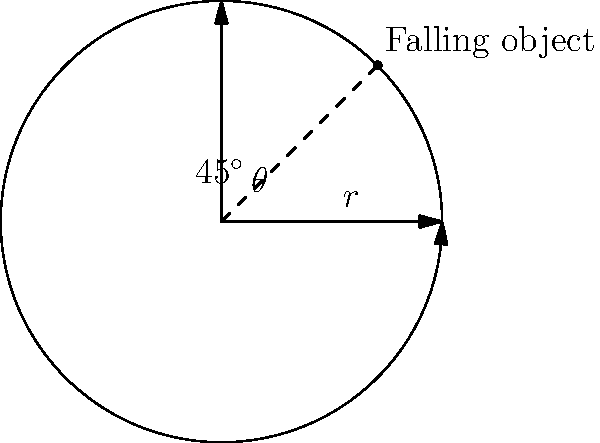As a police officer overseeing a rescue operation, you need to deploy a safety net to catch a falling object. The object is falling at a constant speed in a circular path with a radius of 5 meters. At what angle $\theta$ (in radians) should you position the safety net to catch the object when it's exactly halfway between its highest and lowest points in its circular trajectory? To solve this problem, let's approach it step-by-step:

1) The object is moving in a circular path with a radius of 5 meters.

2) We need to find the angle when the object is halfway between its highest and lowest points.

3) The highest point is at $\theta = \frac{\pi}{2}$ (90°) and the lowest point is at $\theta = \frac{3\pi}{2}$ (270°) in polar coordinates.

4) The halfway point between these two angles is:

   $\theta = \frac{\pi}{2} + \frac{1}{2}(\frac{3\pi}{2} - \frac{\pi}{2}) = \frac{\pi}{2} + \frac{\pi}{2} = \pi$

5) However, this is not the correct answer because we need to consider the symmetry of the circle.

6) The point we're looking for is actually at a 45° angle from the positive x-axis, which is $\frac{\pi}{4}$ radians.

7) We can verify this by calculating the coordinates:
   $x = r \cos(\frac{\pi}{4}) = 5 \cdot \frac{\sqrt{2}}{2} \approx 3.54$
   $y = r \sin(\frac{\pi}{4}) = 5 \cdot \frac{\sqrt{2}}{2} \approx 3.54$

8) These coordinates indeed represent a point halfway between the top and bottom of the circle.

Therefore, the optimal angle to position the safety net is $\frac{\pi}{4}$ radians or 45°.
Answer: $\frac{\pi}{4}$ radians 